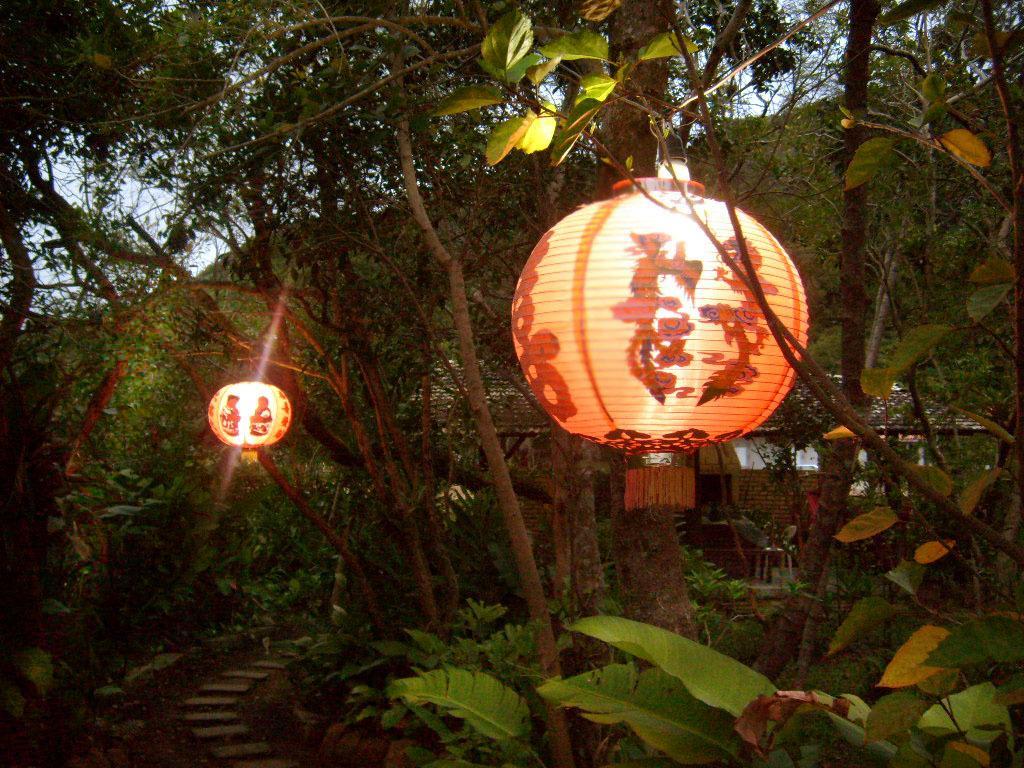How would you summarize this image in a sentence or two? In the center of the image we can see the sky, trees, one house, lanterns and a few other objects. 